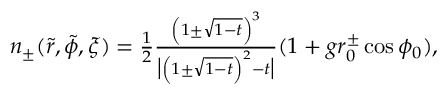<formula> <loc_0><loc_0><loc_500><loc_500>\begin{array} { r } { n _ { \pm } ( \tilde { r } , \tilde { \phi } , \xi ) = \frac { 1 } { 2 } \frac { \left ( 1 \pm \sqrt { 1 - t } \right ) ^ { 3 } } { \left | \left ( 1 \pm \sqrt { 1 - t } \right ) ^ { 2 } - t \right | } ( 1 + g r _ { 0 } ^ { \pm } \cos \phi _ { 0 } ) , } \end{array}</formula> 